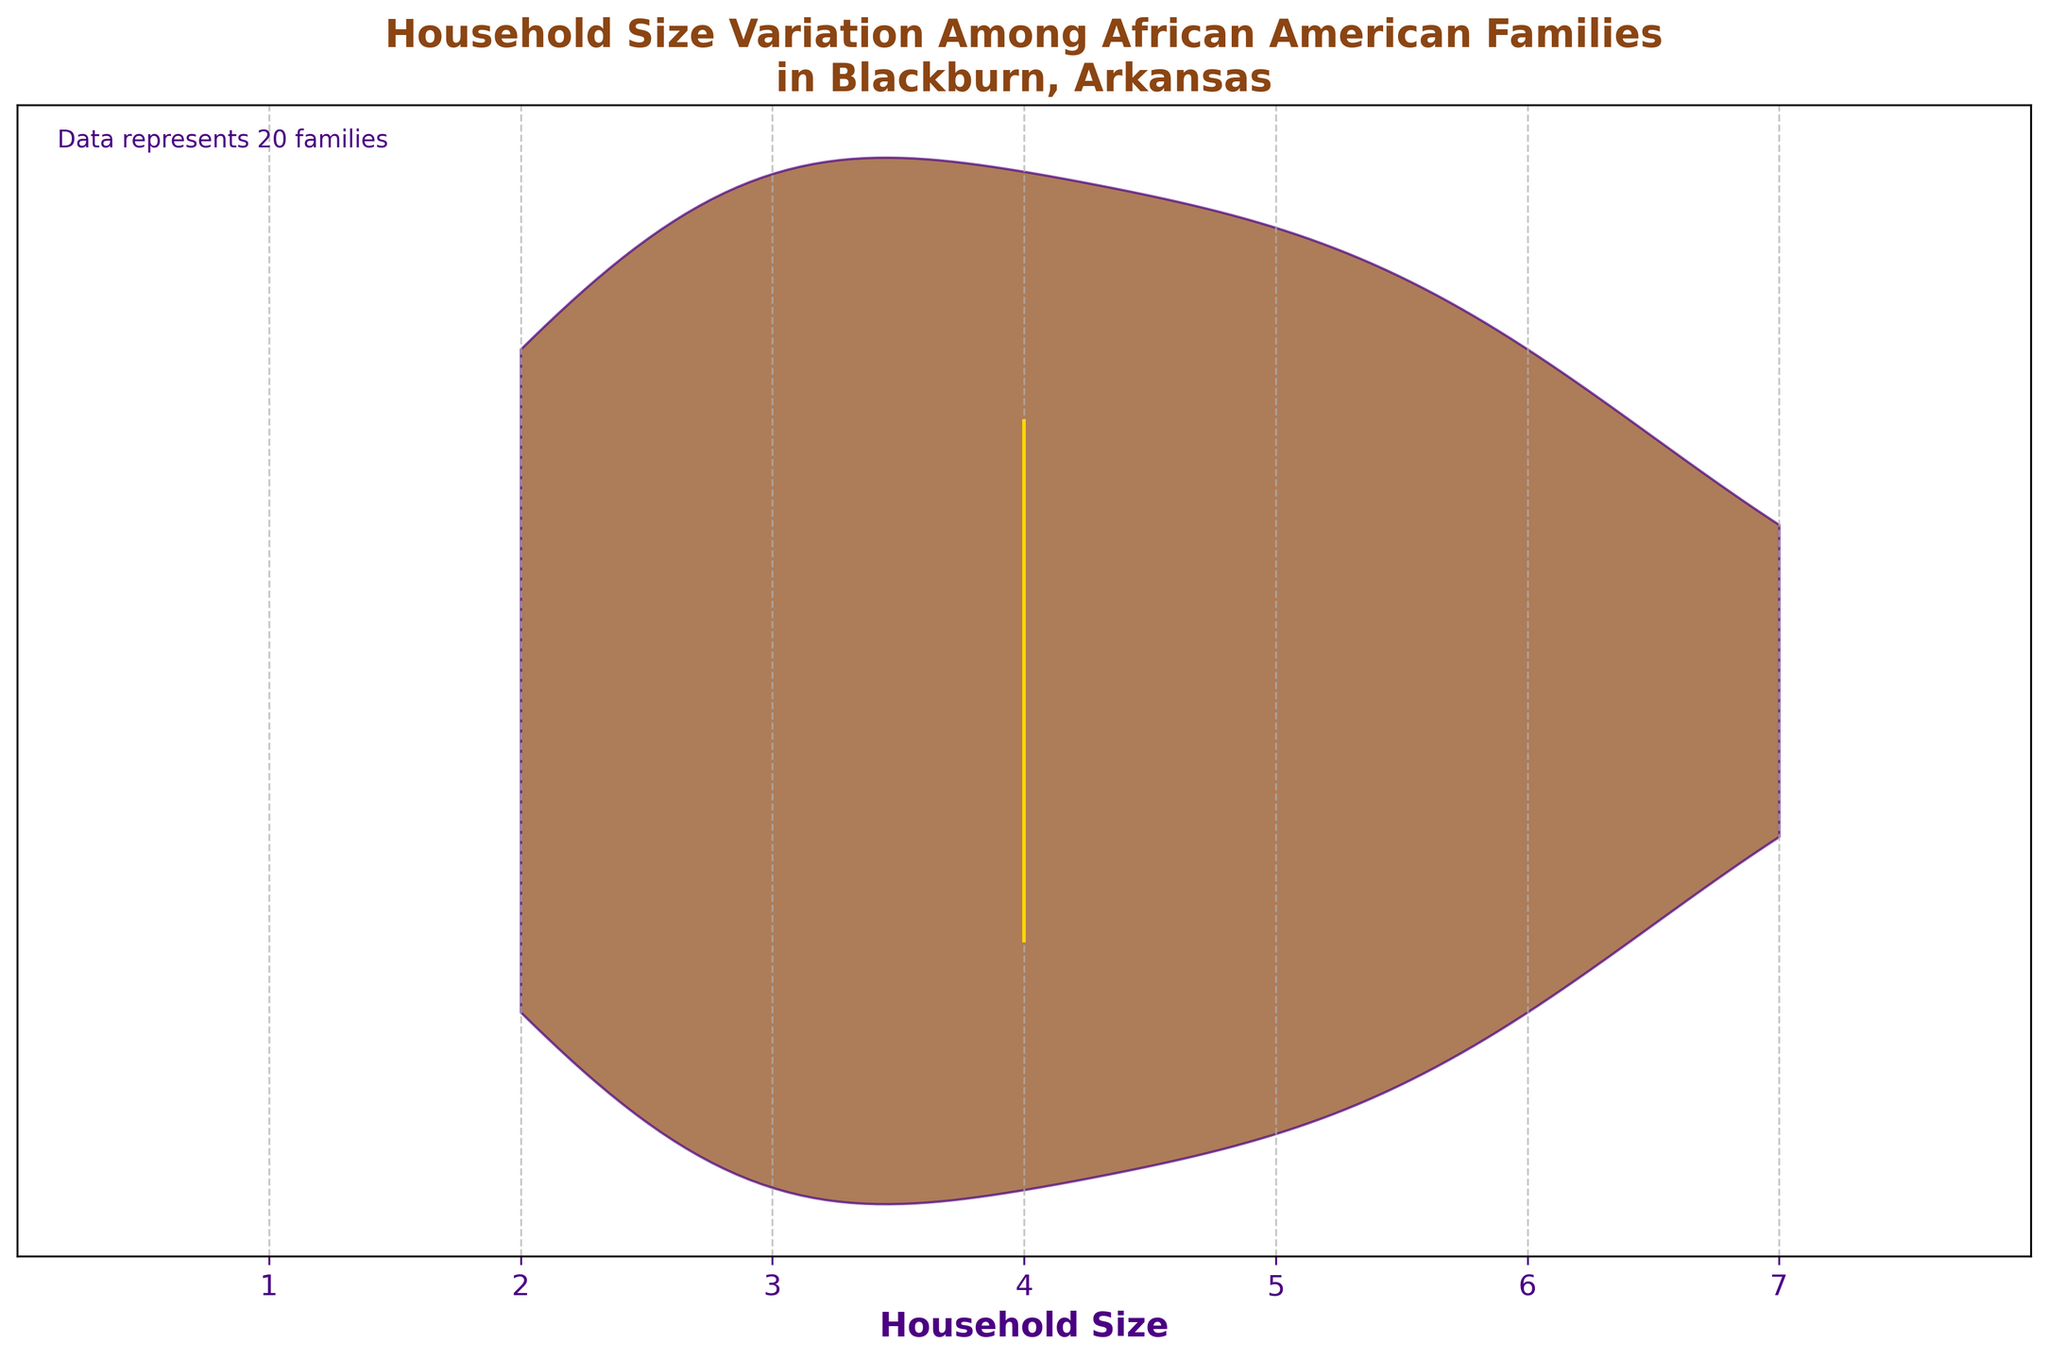What is the title of the violin plot? The title is clearly positioned at the top of the chart in large, bold text, making it easily identifiable.
Answer: Household Size Variation Among African American Families in Blackburn, Arkansas What is the maximum household size shown in the plot? The x-axis ticks show the range of household sizes, with the largest tick representing the maximum size.
Answer: 7 What is the minimum household size observed in the chart? The x-axis ticks indicate the range, with the smallest tick representing the minimum size.
Answer: 2 How many different household sizes are represented in the plot? The x-axis has labels that indicate the different household sizes, which can be counted directly.
Answer: 6 What's the median household size among the families? The median is marked by a horizontal line inside the violin plot, which can be read directly from the x-axis where the line occurs.
Answer: 4 Is the distribution of household sizes symmetric? By observing the shape of the violin plot, one can determine if it is symmetric around the median or skewed.
Answer: No, it's skewed What does the color of the median line represent? The violin plot makes use of specific colors for different elements; the median line is highlighted in gold.
Answer: The gold line represents the median Where is the highest density of household sizes? The widest part of the violin plot indicates where the data is most densely concentrated.
Answer: Around the household size of 3 Do any families fall into the median household size? The number of families at the median household size can be inferred if the plot shows density around the median line.
Answer: Yes How many families have a household size larger than 6? By observing the plot, particularly the areas beyond the household size of 6, the answer can be determined.
Answer: 0 